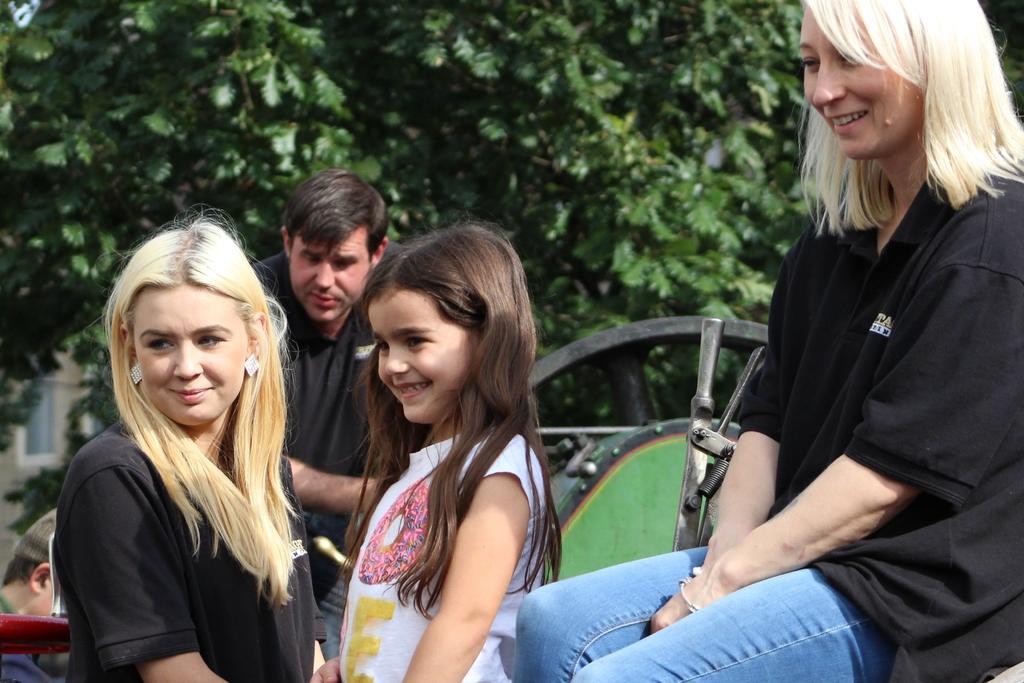In one or two sentences, can you explain what this image depicts? In this picture we can see two women and a girl smiling and at the back of them we can see two people, some objects and in the background we can see trees. 